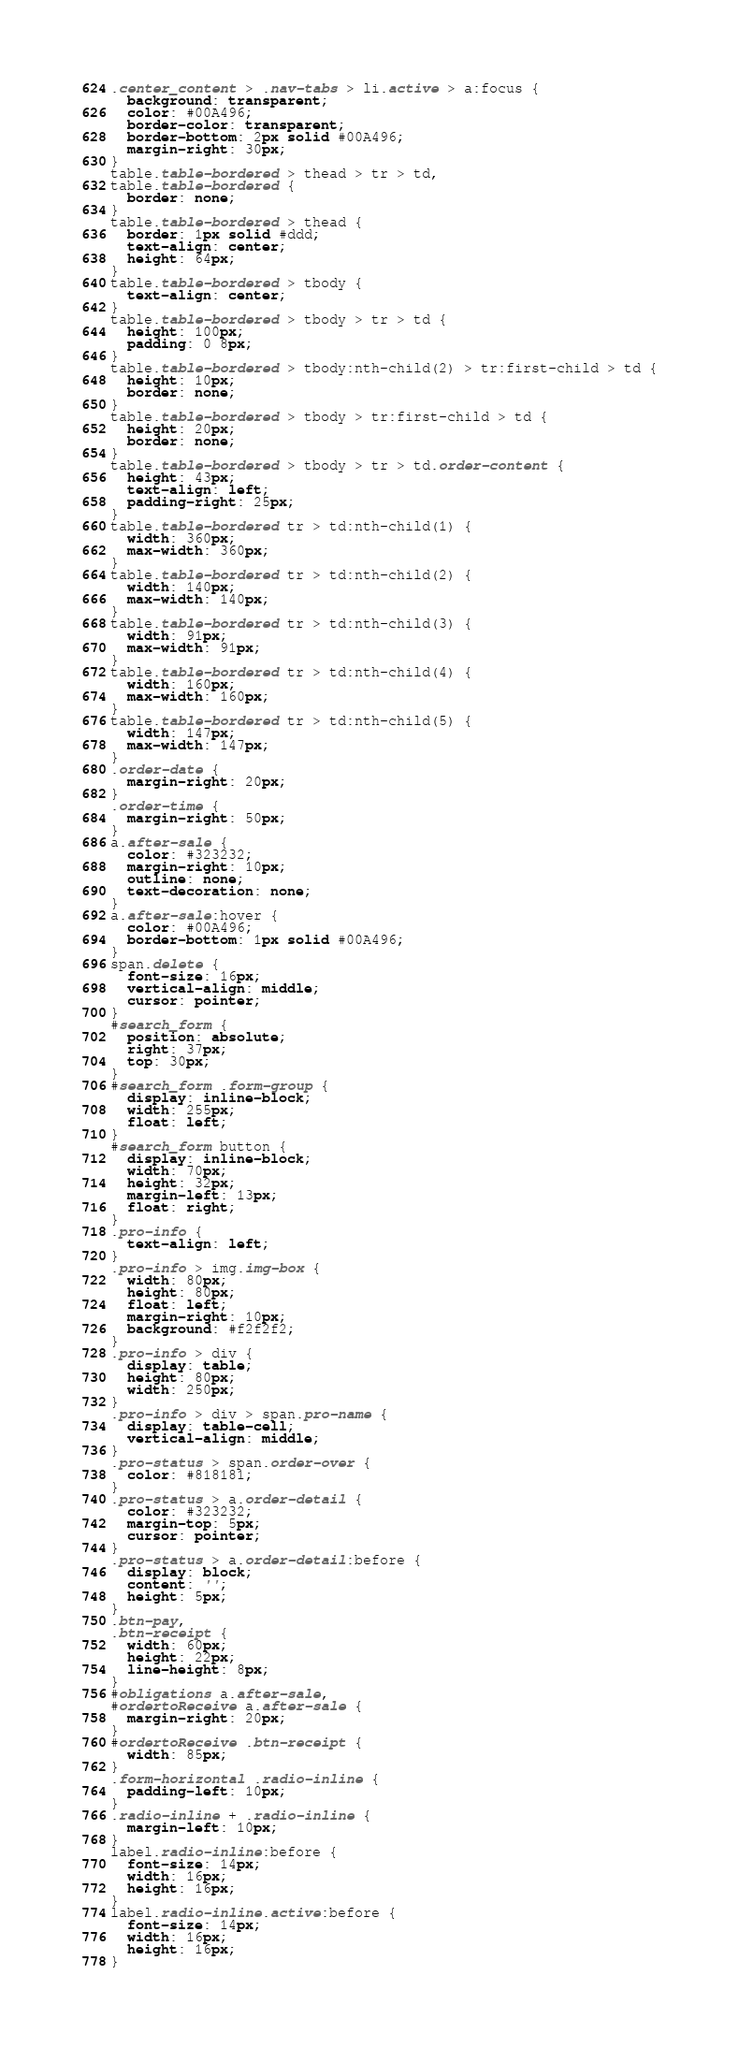<code> <loc_0><loc_0><loc_500><loc_500><_CSS_>.center_content > .nav-tabs > li.active > a:focus {
  background: transparent;
  color: #00A496;
  border-color: transparent;
  border-bottom: 2px solid #00A496;
  margin-right: 30px;
}
table.table-bordered > thead > tr > td,
table.table-bordered {
  border: none;
}
table.table-bordered > thead {
  border: 1px solid #ddd;
  text-align: center;
  height: 64px;
}
table.table-bordered > tbody {
  text-align: center;
}
table.table-bordered > tbody > tr > td {
  height: 100px;
  padding: 0 8px;
}
table.table-bordered > tbody:nth-child(2) > tr:first-child > td {
  height: 10px;
  border: none;
}
table.table-bordered > tbody > tr:first-child > td {
  height: 20px;
  border: none;
}
table.table-bordered > tbody > tr > td.order-content {
  height: 43px;
  text-align: left;
  padding-right: 25px;
}
table.table-bordered tr > td:nth-child(1) {
  width: 360px;
  max-width: 360px;
}
table.table-bordered tr > td:nth-child(2) {
  width: 140px;
  max-width: 140px;
}
table.table-bordered tr > td:nth-child(3) {
  width: 91px;
  max-width: 91px;
}
table.table-bordered tr > td:nth-child(4) {
  width: 160px;
  max-width: 160px;
}
table.table-bordered tr > td:nth-child(5) {
  width: 147px;
  max-width: 147px;
}
.order-date {
  margin-right: 20px;
}
.order-time {
  margin-right: 50px;
}
a.after-sale {
  color: #323232;
  margin-right: 10px;
  outline: none;
  text-decoration: none;
}
a.after-sale:hover {
  color: #00A496;
  border-bottom: 1px solid #00A496;
}
span.delete {
  font-size: 16px;
  vertical-align: middle;
  cursor: pointer;
}
#search_form {
  position: absolute;
  right: 37px;
  top: 30px;
}
#search_form .form-group {
  display: inline-block;
  width: 255px;
  float: left;
}
#search_form button {
  display: inline-block;
  width: 70px;
  height: 32px;
  margin-left: 13px;
  float: right;
}
.pro-info {
  text-align: left;
}
.pro-info > img.img-box {
  width: 80px;
  height: 80px;
  float: left;
  margin-right: 10px;
  background: #f2f2f2;
}
.pro-info > div {
  display: table;
  height: 80px;
  width: 250px;
}
.pro-info > div > span.pro-name {
  display: table-cell;
  vertical-align: middle;
}
.pro-status > span.order-over {
  color: #818181;
}
.pro-status > a.order-detail {
  color: #323232;
  margin-top: 5px;
  cursor: pointer;
}
.pro-status > a.order-detail:before {
  display: block;
  content: '';
  height: 5px;
}
.btn-pay,
.btn-receipt {
  width: 60px;
  height: 22px;
  line-height: 8px;
}
#obligations a.after-sale,
#ordertoReceive a.after-sale {
  margin-right: 20px;
}
#ordertoReceive .btn-receipt {
  width: 85px;
}
.form-horizontal .radio-inline {
  padding-left: 10px;
}
.radio-inline + .radio-inline {
  margin-left: 10px;
}
label.radio-inline:before {
  font-size: 14px;
  width: 16px;
  height: 16px;
}
label.radio-inline.active:before {
  font-size: 14px;
  width: 16px;
  height: 16px;
}
</code> 